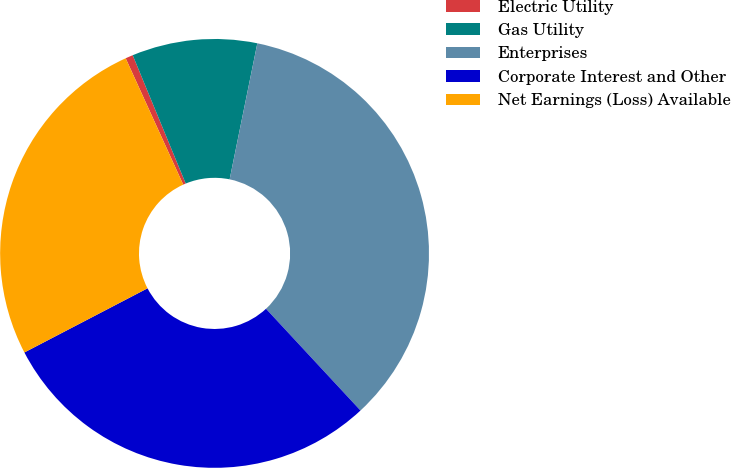Convert chart. <chart><loc_0><loc_0><loc_500><loc_500><pie_chart><fcel>Electric Utility<fcel>Gas Utility<fcel>Enterprises<fcel>Corporate Interest and Other<fcel>Net Earnings (Loss) Available<nl><fcel>0.57%<fcel>9.43%<fcel>34.89%<fcel>29.27%<fcel>25.84%<nl></chart> 